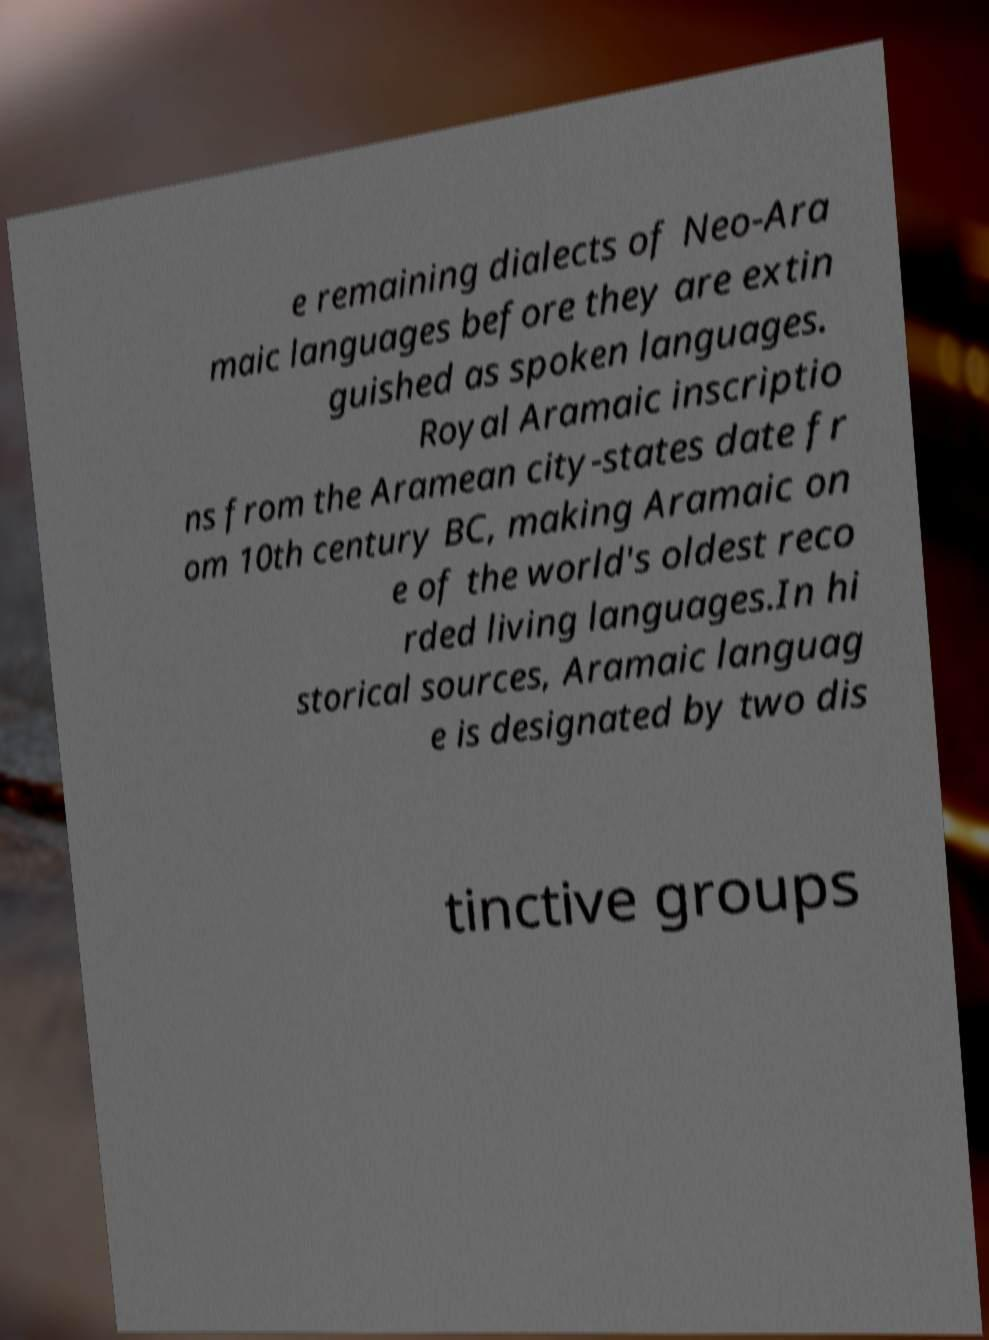I need the written content from this picture converted into text. Can you do that? e remaining dialects of Neo-Ara maic languages before they are extin guished as spoken languages. Royal Aramaic inscriptio ns from the Aramean city-states date fr om 10th century BC, making Aramaic on e of the world's oldest reco rded living languages.In hi storical sources, Aramaic languag e is designated by two dis tinctive groups 